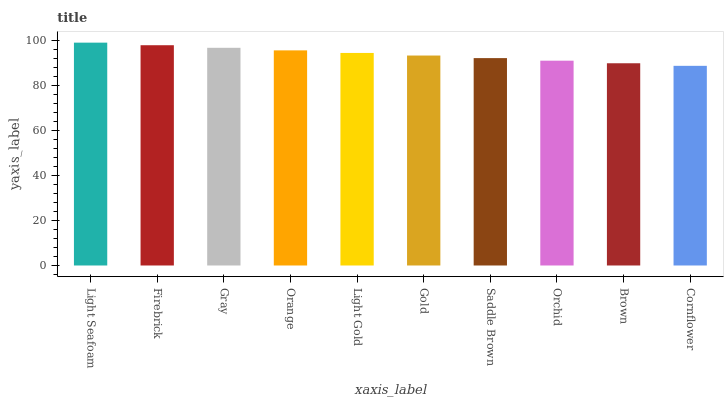Is Cornflower the minimum?
Answer yes or no. Yes. Is Light Seafoam the maximum?
Answer yes or no. Yes. Is Firebrick the minimum?
Answer yes or no. No. Is Firebrick the maximum?
Answer yes or no. No. Is Light Seafoam greater than Firebrick?
Answer yes or no. Yes. Is Firebrick less than Light Seafoam?
Answer yes or no. Yes. Is Firebrick greater than Light Seafoam?
Answer yes or no. No. Is Light Seafoam less than Firebrick?
Answer yes or no. No. Is Light Gold the high median?
Answer yes or no. Yes. Is Gold the low median?
Answer yes or no. Yes. Is Saddle Brown the high median?
Answer yes or no. No. Is Cornflower the low median?
Answer yes or no. No. 